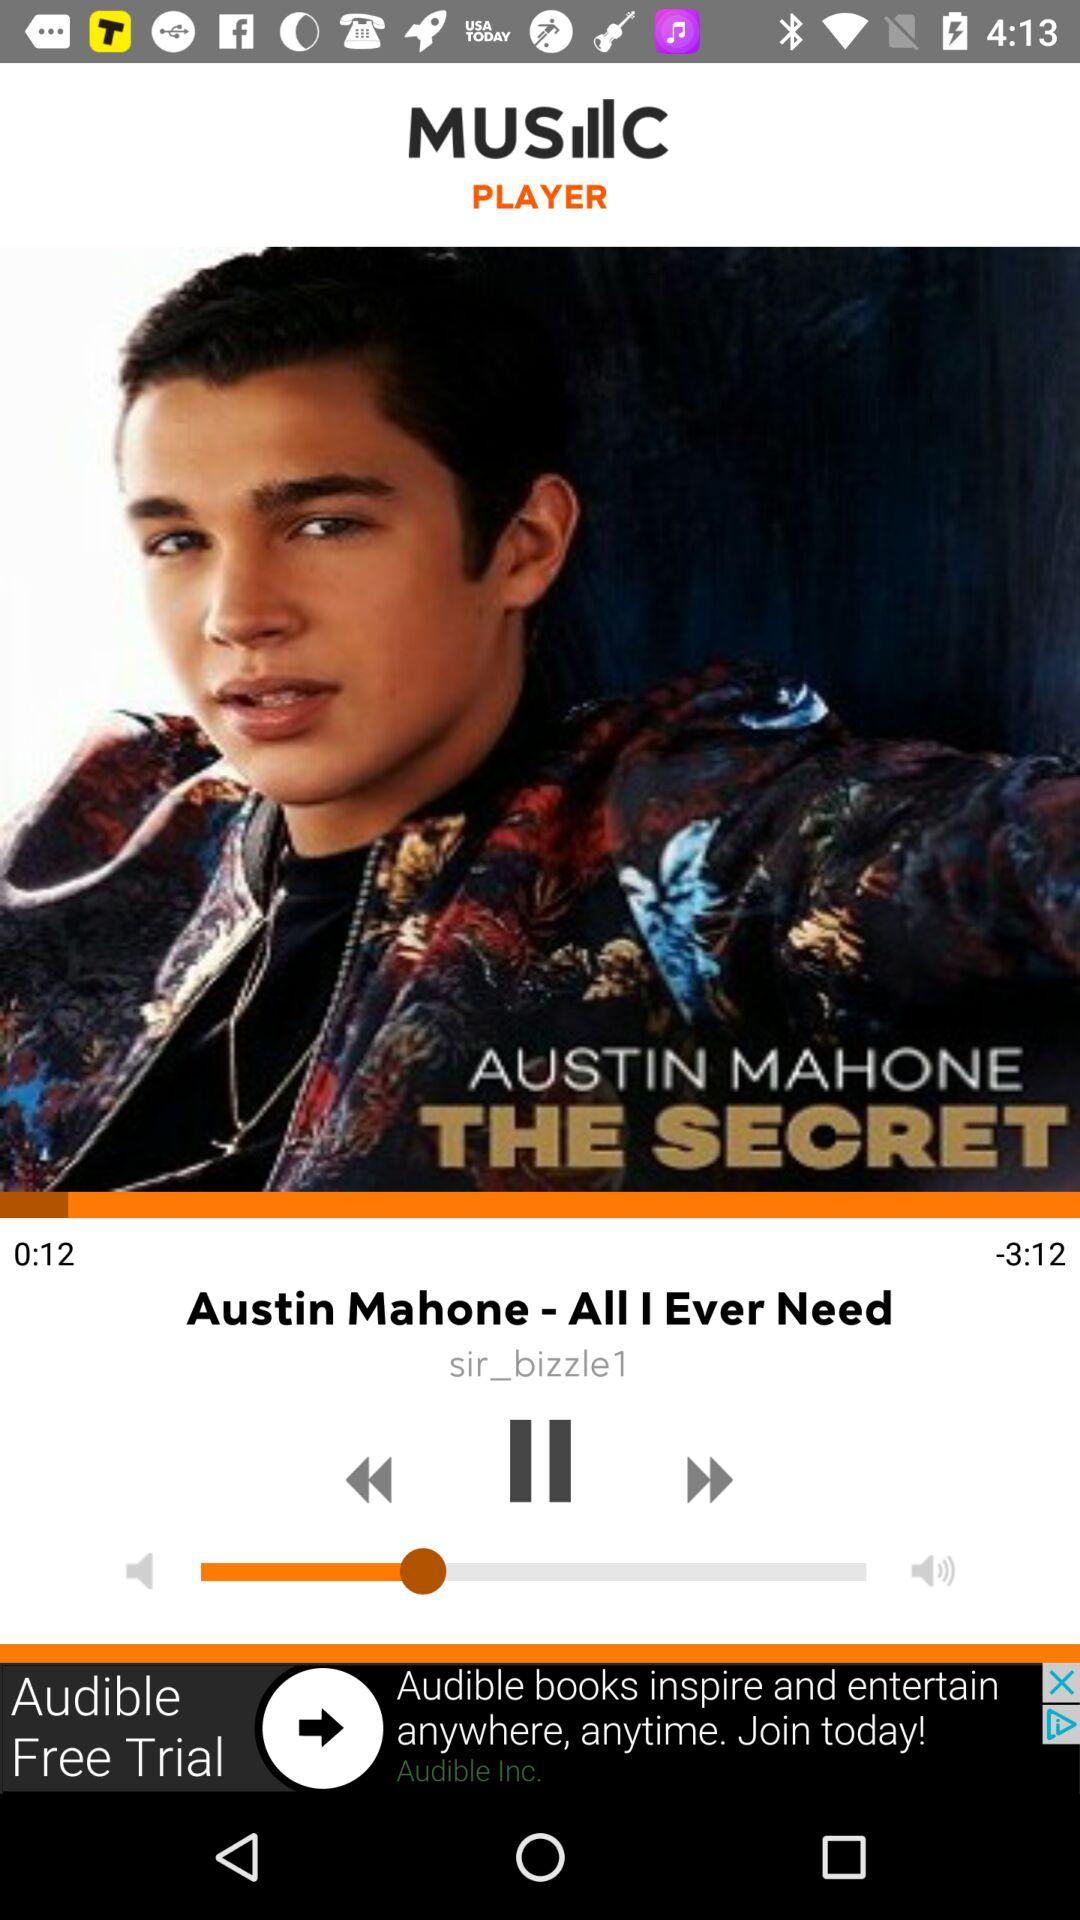What is the name of the singer? The name of the singer is Austin Mahone. 